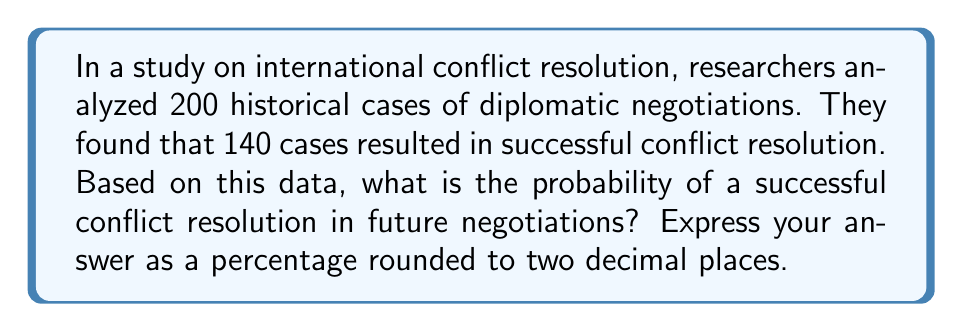Provide a solution to this math problem. To solve this problem, we need to use the concept of probability based on historical data. The probability of an event is calculated by dividing the number of favorable outcomes by the total number of possible outcomes.

Let's break down the given information:
- Total number of cases: $n = 200$
- Number of successful resolutions: $k = 140$

The probability of a successful conflict resolution is calculated as follows:

$$P(\text{success}) = \frac{\text{Number of successful cases}}{\text{Total number of cases}}$$

$$P(\text{success}) = \frac{k}{n} = \frac{140}{200}$$

To simplify this fraction:

$$\frac{140}{200} = \frac{7}{10} = 0.7$$

To express this as a percentage, we multiply by 100:

$$0.7 \times 100 = 70\%$$

Therefore, based on the historical data, the probability of a successful conflict resolution in future negotiations is 70%.
Answer: 70.00% 